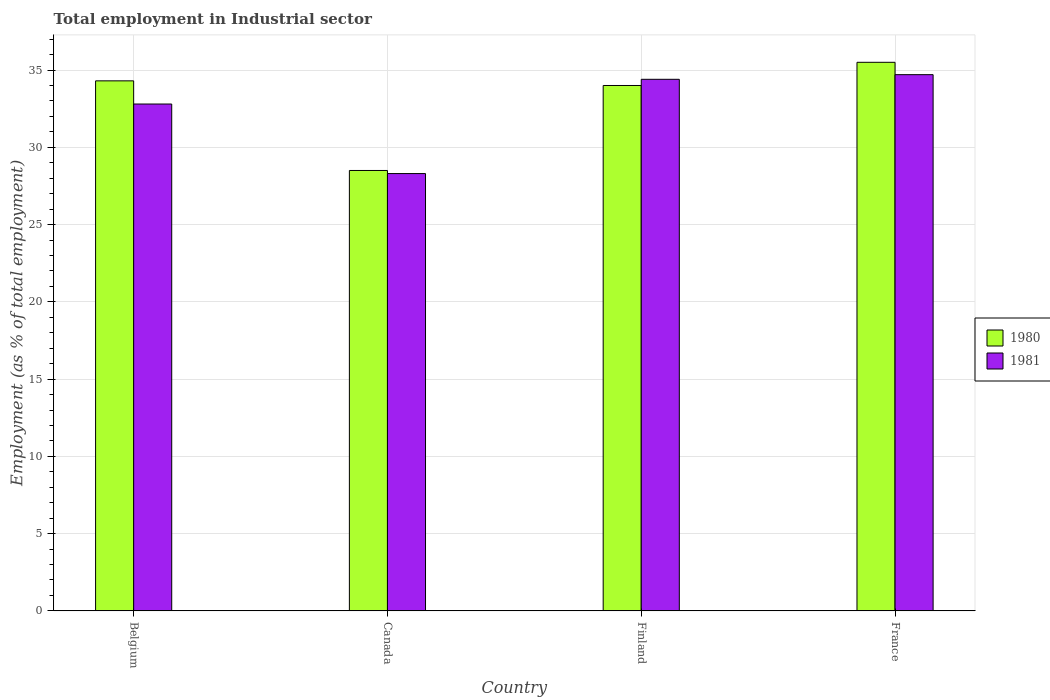Are the number of bars per tick equal to the number of legend labels?
Keep it short and to the point. Yes. Are the number of bars on each tick of the X-axis equal?
Offer a terse response. Yes. How many bars are there on the 1st tick from the left?
Provide a short and direct response. 2. How many bars are there on the 3rd tick from the right?
Offer a very short reply. 2. What is the label of the 2nd group of bars from the left?
Provide a succinct answer. Canada. In how many cases, is the number of bars for a given country not equal to the number of legend labels?
Your answer should be very brief. 0. What is the employment in industrial sector in 1980 in Finland?
Give a very brief answer. 34. Across all countries, what is the maximum employment in industrial sector in 1980?
Give a very brief answer. 35.5. Across all countries, what is the minimum employment in industrial sector in 1981?
Keep it short and to the point. 28.3. What is the total employment in industrial sector in 1981 in the graph?
Give a very brief answer. 130.2. What is the difference between the employment in industrial sector in 1981 in Belgium and that in Finland?
Make the answer very short. -1.6. What is the difference between the employment in industrial sector in 1981 in France and the employment in industrial sector in 1980 in Finland?
Offer a terse response. 0.7. What is the average employment in industrial sector in 1981 per country?
Keep it short and to the point. 32.55. What is the difference between the employment in industrial sector of/in 1980 and employment in industrial sector of/in 1981 in Finland?
Make the answer very short. -0.4. What is the ratio of the employment in industrial sector in 1980 in Finland to that in France?
Offer a terse response. 0.96. What is the difference between the highest and the second highest employment in industrial sector in 1980?
Offer a very short reply. -1.2. What is the difference between the highest and the lowest employment in industrial sector in 1980?
Ensure brevity in your answer.  7. What does the 1st bar from the right in Belgium represents?
Your answer should be compact. 1981. Are the values on the major ticks of Y-axis written in scientific E-notation?
Offer a very short reply. No. How many legend labels are there?
Provide a succinct answer. 2. What is the title of the graph?
Offer a terse response. Total employment in Industrial sector. Does "1979" appear as one of the legend labels in the graph?
Your answer should be compact. No. What is the label or title of the Y-axis?
Your answer should be very brief. Employment (as % of total employment). What is the Employment (as % of total employment) of 1980 in Belgium?
Make the answer very short. 34.3. What is the Employment (as % of total employment) of 1981 in Belgium?
Ensure brevity in your answer.  32.8. What is the Employment (as % of total employment) of 1980 in Canada?
Your answer should be compact. 28.5. What is the Employment (as % of total employment) in 1981 in Canada?
Keep it short and to the point. 28.3. What is the Employment (as % of total employment) in 1981 in Finland?
Offer a very short reply. 34.4. What is the Employment (as % of total employment) in 1980 in France?
Provide a short and direct response. 35.5. What is the Employment (as % of total employment) in 1981 in France?
Provide a succinct answer. 34.7. Across all countries, what is the maximum Employment (as % of total employment) in 1980?
Make the answer very short. 35.5. Across all countries, what is the maximum Employment (as % of total employment) of 1981?
Your answer should be very brief. 34.7. Across all countries, what is the minimum Employment (as % of total employment) in 1980?
Your answer should be very brief. 28.5. Across all countries, what is the minimum Employment (as % of total employment) in 1981?
Offer a very short reply. 28.3. What is the total Employment (as % of total employment) of 1980 in the graph?
Keep it short and to the point. 132.3. What is the total Employment (as % of total employment) of 1981 in the graph?
Make the answer very short. 130.2. What is the difference between the Employment (as % of total employment) in 1981 in Belgium and that in Canada?
Make the answer very short. 4.5. What is the difference between the Employment (as % of total employment) in 1981 in Belgium and that in Finland?
Provide a short and direct response. -1.6. What is the difference between the Employment (as % of total employment) in 1980 in Canada and that in France?
Make the answer very short. -7. What is the difference between the Employment (as % of total employment) of 1981 in Canada and that in France?
Your response must be concise. -6.4. What is the difference between the Employment (as % of total employment) of 1981 in Finland and that in France?
Provide a succinct answer. -0.3. What is the difference between the Employment (as % of total employment) of 1980 in Belgium and the Employment (as % of total employment) of 1981 in Finland?
Your answer should be very brief. -0.1. What is the average Employment (as % of total employment) in 1980 per country?
Provide a succinct answer. 33.08. What is the average Employment (as % of total employment) of 1981 per country?
Your answer should be very brief. 32.55. What is the difference between the Employment (as % of total employment) of 1980 and Employment (as % of total employment) of 1981 in Canada?
Keep it short and to the point. 0.2. What is the difference between the Employment (as % of total employment) in 1980 and Employment (as % of total employment) in 1981 in France?
Make the answer very short. 0.8. What is the ratio of the Employment (as % of total employment) of 1980 in Belgium to that in Canada?
Your answer should be very brief. 1.2. What is the ratio of the Employment (as % of total employment) in 1981 in Belgium to that in Canada?
Your answer should be compact. 1.16. What is the ratio of the Employment (as % of total employment) of 1980 in Belgium to that in Finland?
Your answer should be compact. 1.01. What is the ratio of the Employment (as % of total employment) in 1981 in Belgium to that in Finland?
Keep it short and to the point. 0.95. What is the ratio of the Employment (as % of total employment) in 1980 in Belgium to that in France?
Your answer should be very brief. 0.97. What is the ratio of the Employment (as % of total employment) in 1981 in Belgium to that in France?
Give a very brief answer. 0.95. What is the ratio of the Employment (as % of total employment) in 1980 in Canada to that in Finland?
Give a very brief answer. 0.84. What is the ratio of the Employment (as % of total employment) of 1981 in Canada to that in Finland?
Provide a short and direct response. 0.82. What is the ratio of the Employment (as % of total employment) in 1980 in Canada to that in France?
Your answer should be compact. 0.8. What is the ratio of the Employment (as % of total employment) of 1981 in Canada to that in France?
Give a very brief answer. 0.82. What is the ratio of the Employment (as % of total employment) in 1980 in Finland to that in France?
Offer a terse response. 0.96. What is the ratio of the Employment (as % of total employment) in 1981 in Finland to that in France?
Your response must be concise. 0.99. What is the difference between the highest and the lowest Employment (as % of total employment) of 1980?
Your response must be concise. 7. 